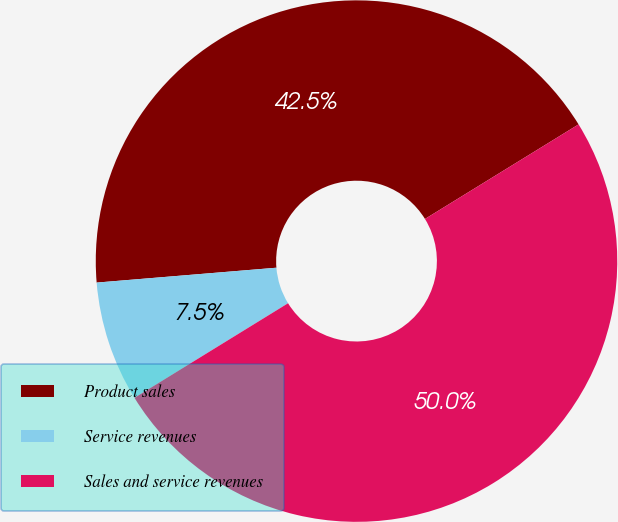<chart> <loc_0><loc_0><loc_500><loc_500><pie_chart><fcel>Product sales<fcel>Service revenues<fcel>Sales and service revenues<nl><fcel>42.53%<fcel>7.47%<fcel>50.0%<nl></chart> 